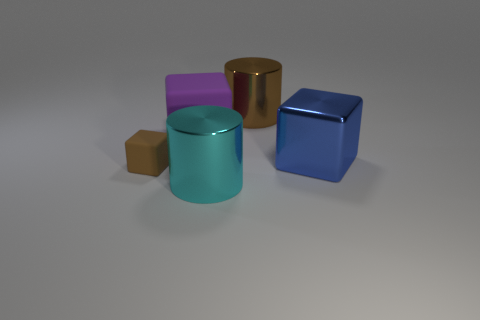Add 4 brown cylinders. How many objects exist? 9 Subtract all blocks. How many objects are left? 2 Subtract 0 gray spheres. How many objects are left? 5 Subtract all cylinders. Subtract all small brown matte cubes. How many objects are left? 2 Add 5 large brown shiny cylinders. How many large brown shiny cylinders are left? 6 Add 1 tiny yellow metal things. How many tiny yellow metal things exist? 1 